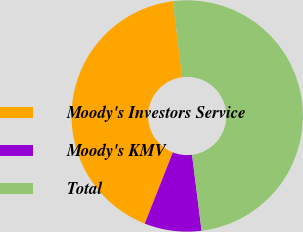Convert chart. <chart><loc_0><loc_0><loc_500><loc_500><pie_chart><fcel>Moody's Investors Service<fcel>Moody's KMV<fcel>Total<nl><fcel>42.04%<fcel>7.96%<fcel>50.0%<nl></chart> 